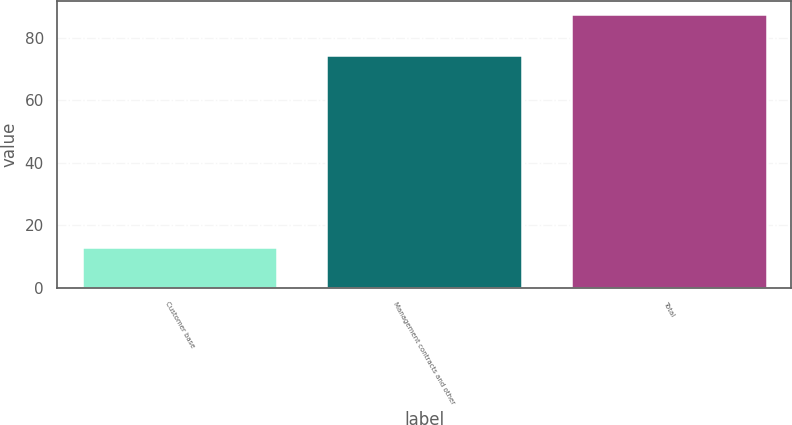<chart> <loc_0><loc_0><loc_500><loc_500><bar_chart><fcel>Customer base<fcel>Management contracts and other<fcel>Total<nl><fcel>12.9<fcel>74.6<fcel>87.5<nl></chart> 